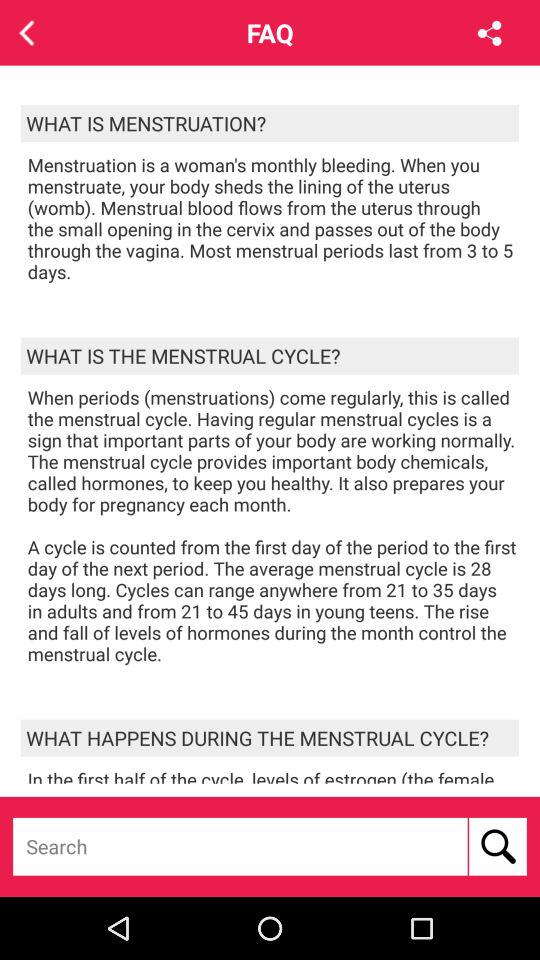How many days long is the average menstrual cycle?
Answer the question using a single word or phrase. 28 days 